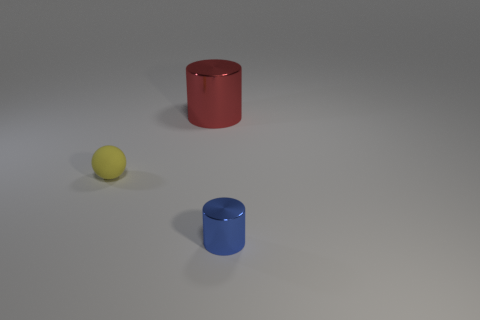Add 3 cylinders. How many objects exist? 6 Subtract all balls. How many objects are left? 2 Add 2 tiny yellow spheres. How many tiny yellow spheres are left? 3 Add 2 blue blocks. How many blue blocks exist? 2 Subtract 0 brown balls. How many objects are left? 3 Subtract all large green rubber spheres. Subtract all small matte things. How many objects are left? 2 